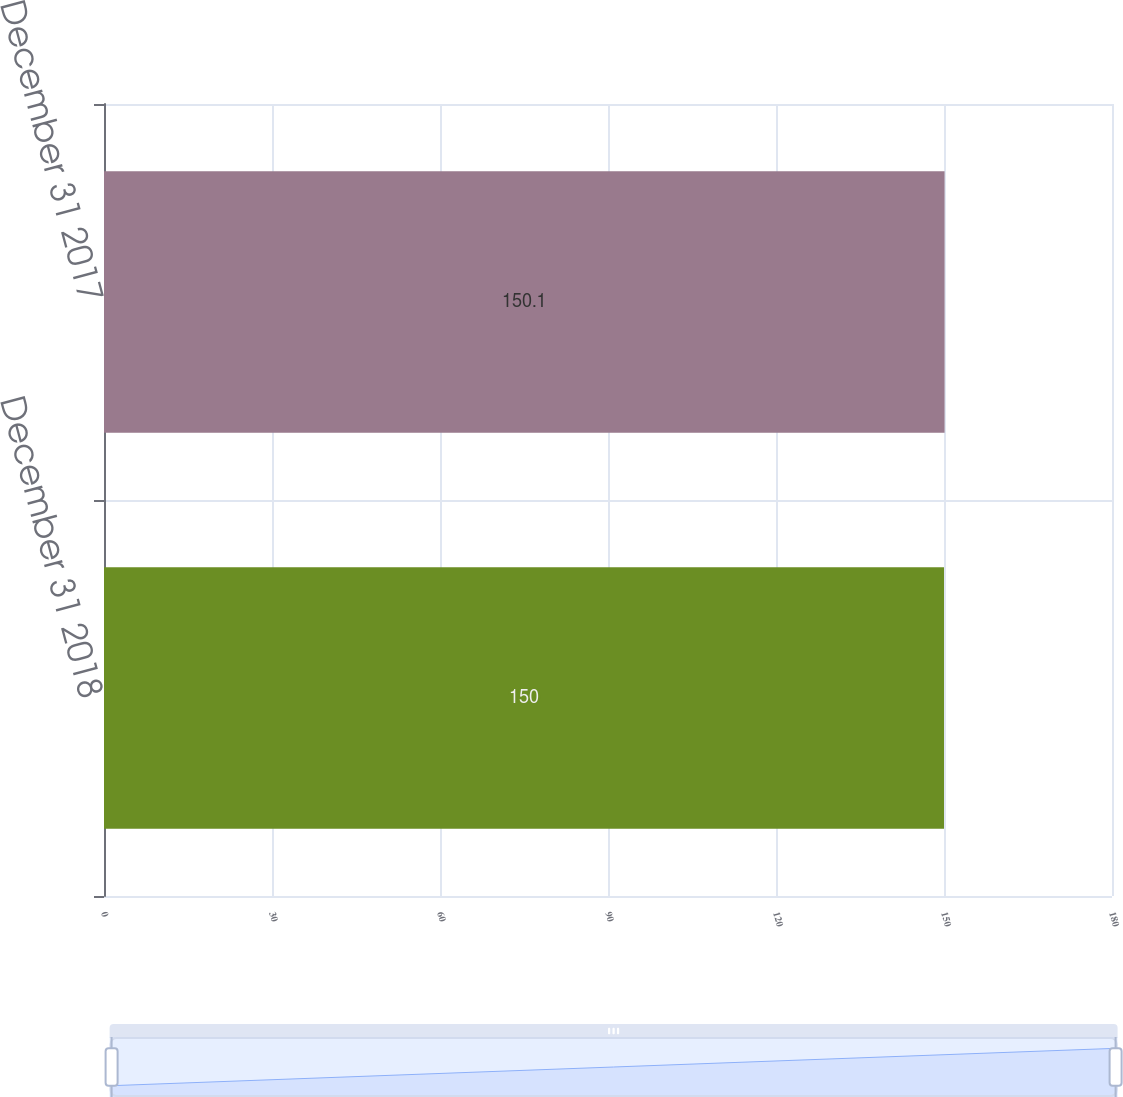Convert chart to OTSL. <chart><loc_0><loc_0><loc_500><loc_500><bar_chart><fcel>December 31 2018<fcel>December 31 2017<nl><fcel>150<fcel>150.1<nl></chart> 